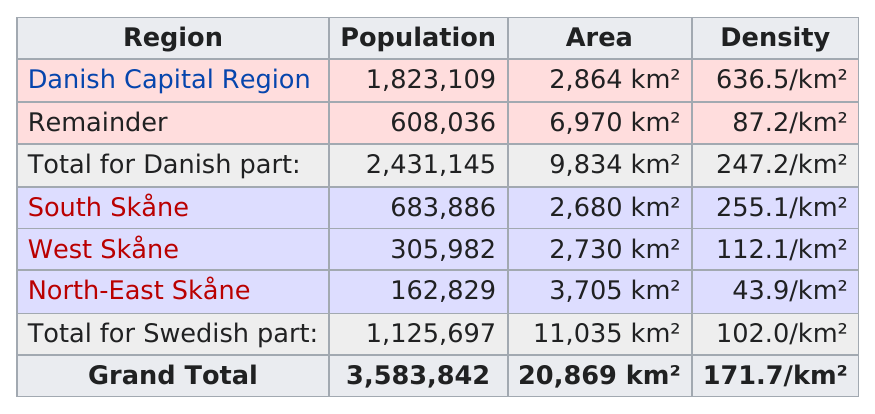Highlight a few significant elements in this photo. There are three regions that make up the Swedish part. The Danish Capital Region has the highest population among all regions in Denmark. The Danish Capital Region has the highest population among the regions in the Danish part. Of the regions with a population of over one million, I have visited 1 through n. The Swedish or the Danish part has a higher population. 